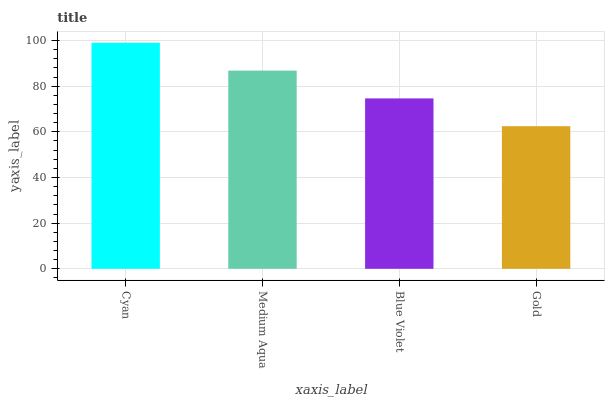Is Gold the minimum?
Answer yes or no. Yes. Is Cyan the maximum?
Answer yes or no. Yes. Is Medium Aqua the minimum?
Answer yes or no. No. Is Medium Aqua the maximum?
Answer yes or no. No. Is Cyan greater than Medium Aqua?
Answer yes or no. Yes. Is Medium Aqua less than Cyan?
Answer yes or no. Yes. Is Medium Aqua greater than Cyan?
Answer yes or no. No. Is Cyan less than Medium Aqua?
Answer yes or no. No. Is Medium Aqua the high median?
Answer yes or no. Yes. Is Blue Violet the low median?
Answer yes or no. Yes. Is Gold the high median?
Answer yes or no. No. Is Cyan the low median?
Answer yes or no. No. 